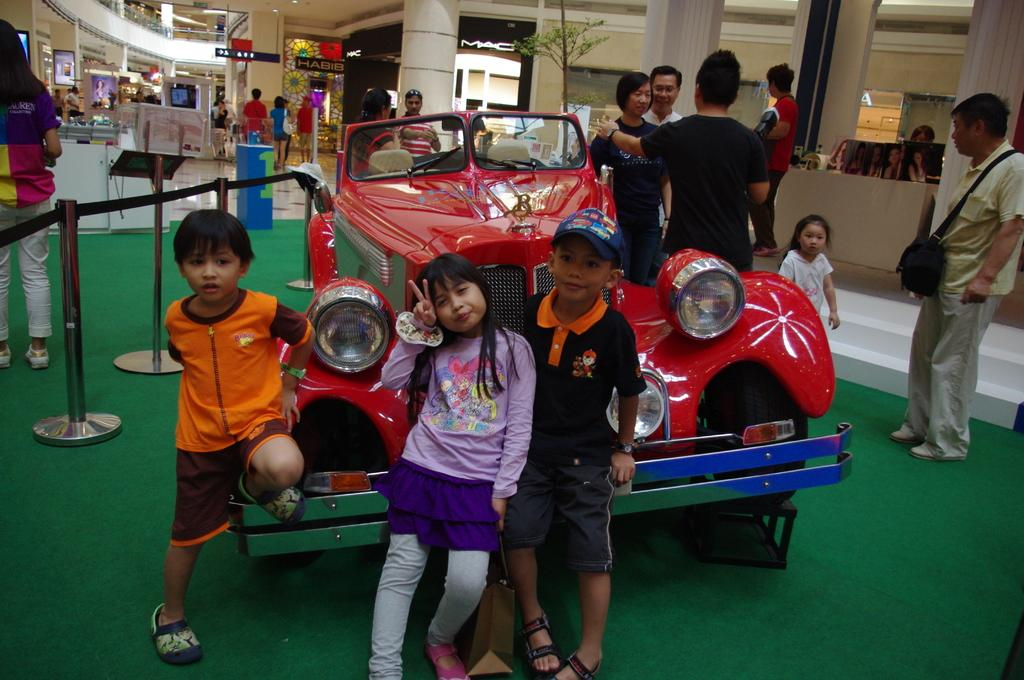How many people are in the group visible in the image? There is a group of people standing in the image, but the exact number is not specified. What type of vehicle can be seen in the image? There is a vehicle in the image, but its specific type is not mentioned. What are the stanchion barriers used for in the image? The purpose of the stanchion barriers in the image is not specified. What can be found on the boards in the image? The content or purpose of the boards in the image is not mentioned. What type of shops are present in the image? The specific type of shops in the image is not mentioned. What are the pillars supporting in the image? The purpose or structure supported by the pillars in the image is not specified. Can you describe the unspecified objects in the image? The unspecified objects in the image are not described in the provided facts. What type of police behavior can be observed in the image? A: There is no mention of police or any related behavior in the image. What is the title of the book displayed on the boards in the image? The content or purpose of the boards in the image is not mentioned, so it is impossible to determine if there is a book or its title. 